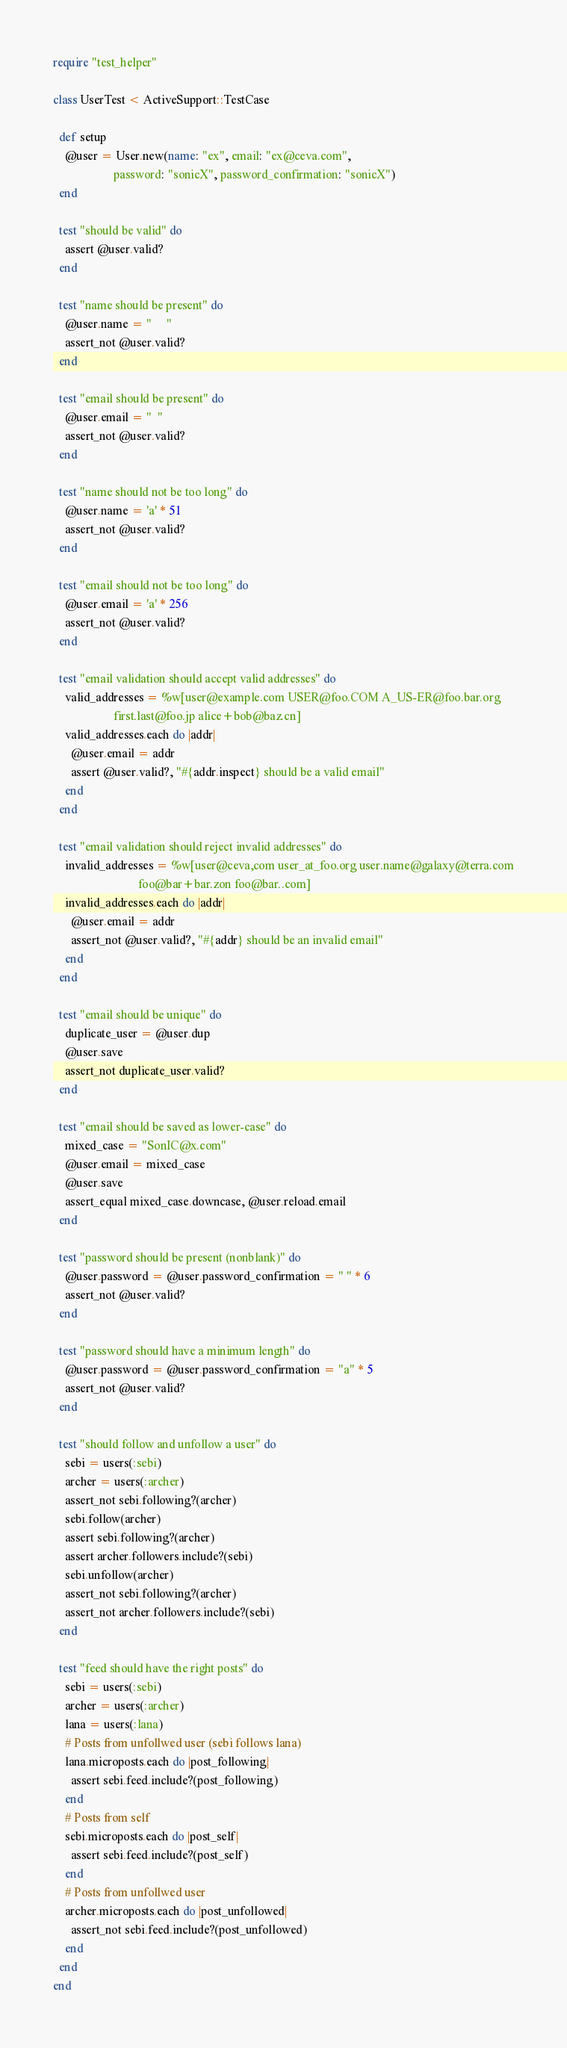<code> <loc_0><loc_0><loc_500><loc_500><_Ruby_>require "test_helper"

class UserTest < ActiveSupport::TestCase

  def setup
    @user = User.new(name: "ex", email: "ex@ceva.com",
                    password: "sonicX", password_confirmation: "sonicX")
  end

  test "should be valid" do
    assert @user.valid?
  end

  test "name should be present" do
    @user.name = "     "
    assert_not @user.valid?
  end

  test "email should be present" do
    @user.email = "  "
    assert_not @user.valid?
  end

  test "name should not be too long" do
    @user.name = 'a' * 51
    assert_not @user.valid?
  end

  test "email should not be too long" do
    @user.email = 'a' * 256
    assert_not @user.valid?
  end

  test "email validation should accept valid addresses" do
    valid_addresses = %w[user@example.com USER@foo.COM A_US-ER@foo.bar.org
                    first.last@foo.jp alice+bob@baz.cn]
    valid_addresses.each do |addr|
      @user.email = addr
      assert @user.valid?, "#{addr.inspect} should be a valid email"
    end
  end

  test "email validation should reject invalid addresses" do
    invalid_addresses = %w[user@ceva,com user_at_foo.org user.name@galaxy@terra.com
                            foo@bar+bar.zon foo@bar..com]
    invalid_addresses.each do |addr|
      @user.email = addr
      assert_not @user.valid?, "#{addr} should be an invalid email"
    end
  end

  test "email should be unique" do
    duplicate_user = @user.dup
    @user.save
    assert_not duplicate_user.valid?
  end

  test "email should be saved as lower-case" do
    mixed_case = "SonIC@x.com"
    @user.email = mixed_case
    @user.save
    assert_equal mixed_case.downcase, @user.reload.email
  end

  test "password should be present (nonblank)" do
    @user.password = @user.password_confirmation = " " * 6
    assert_not @user.valid?
  end

  test "password should have a minimum length" do
    @user.password = @user.password_confirmation = "a" * 5
    assert_not @user.valid?
  end

  test "should follow and unfollow a user" do
    sebi = users(:sebi)
    archer = users(:archer)
    assert_not sebi.following?(archer)
    sebi.follow(archer)
    assert sebi.following?(archer)
    assert archer.followers.include?(sebi)
    sebi.unfollow(archer)
    assert_not sebi.following?(archer)
    assert_not archer.followers.include?(sebi)
  end

  test "feed should have the right posts" do
    sebi = users(:sebi)
    archer = users(:archer)
    lana = users(:lana)
    # Posts from unfollwed user (sebi follows lana)
    lana.microposts.each do |post_following|
      assert sebi.feed.include?(post_following)
    end
    # Posts from self
    sebi.microposts.each do |post_self|
      assert sebi.feed.include?(post_self)
    end
    # Posts from unfollwed user
    archer.microposts.each do |post_unfollowed|
      assert_not sebi.feed.include?(post_unfollowed)
    end
  end
end
</code> 